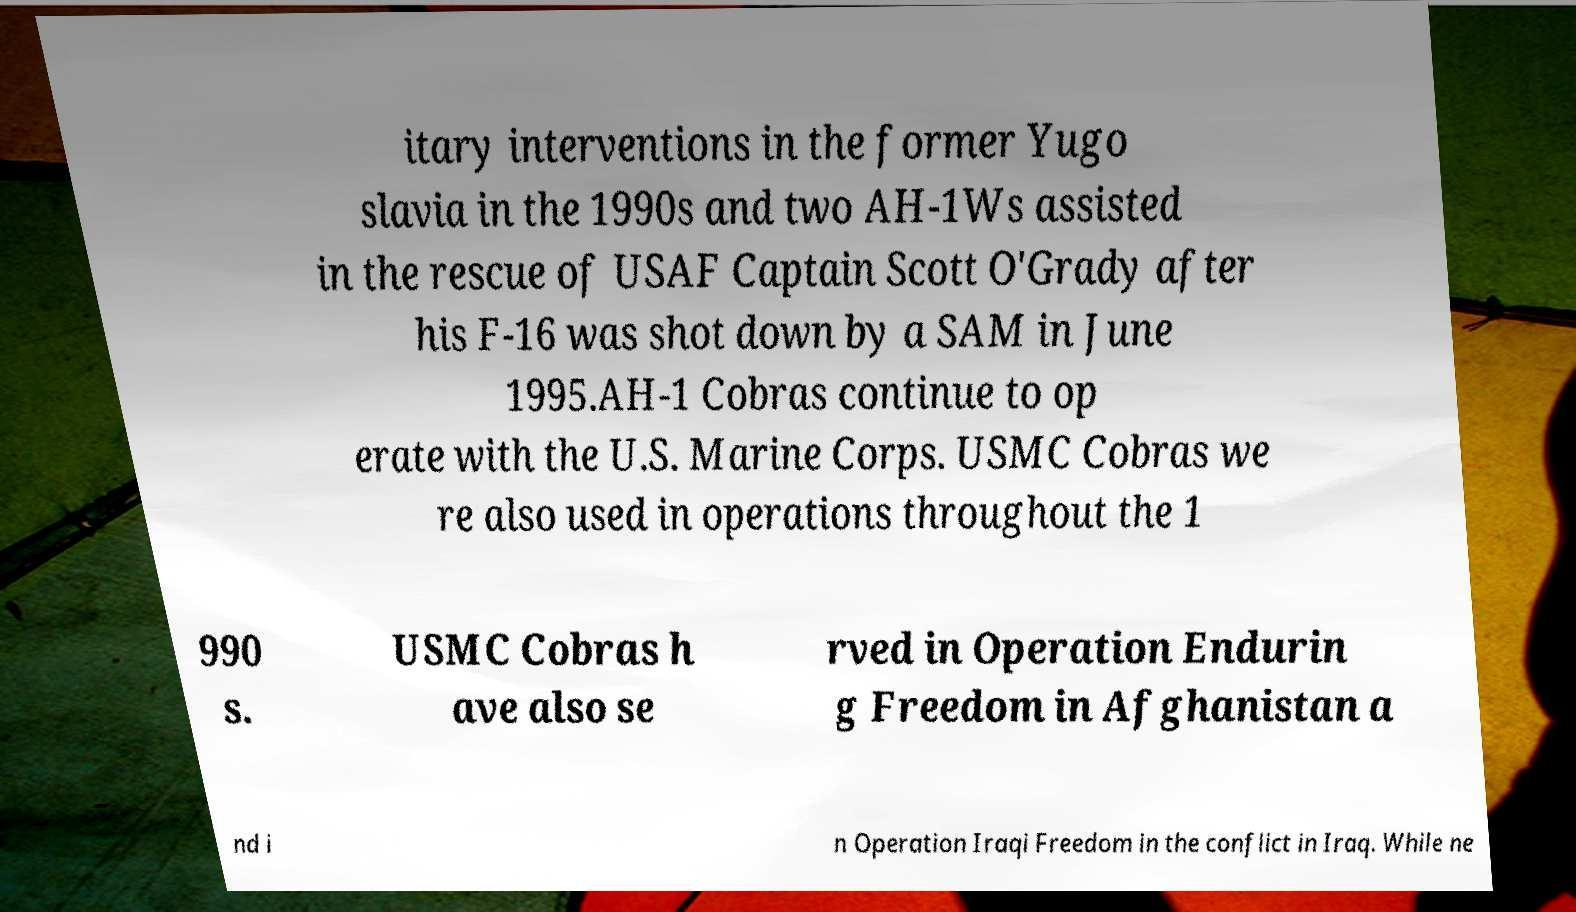Can you accurately transcribe the text from the provided image for me? itary interventions in the former Yugo slavia in the 1990s and two AH-1Ws assisted in the rescue of USAF Captain Scott O'Grady after his F-16 was shot down by a SAM in June 1995.AH-1 Cobras continue to op erate with the U.S. Marine Corps. USMC Cobras we re also used in operations throughout the 1 990 s. USMC Cobras h ave also se rved in Operation Endurin g Freedom in Afghanistan a nd i n Operation Iraqi Freedom in the conflict in Iraq. While ne 